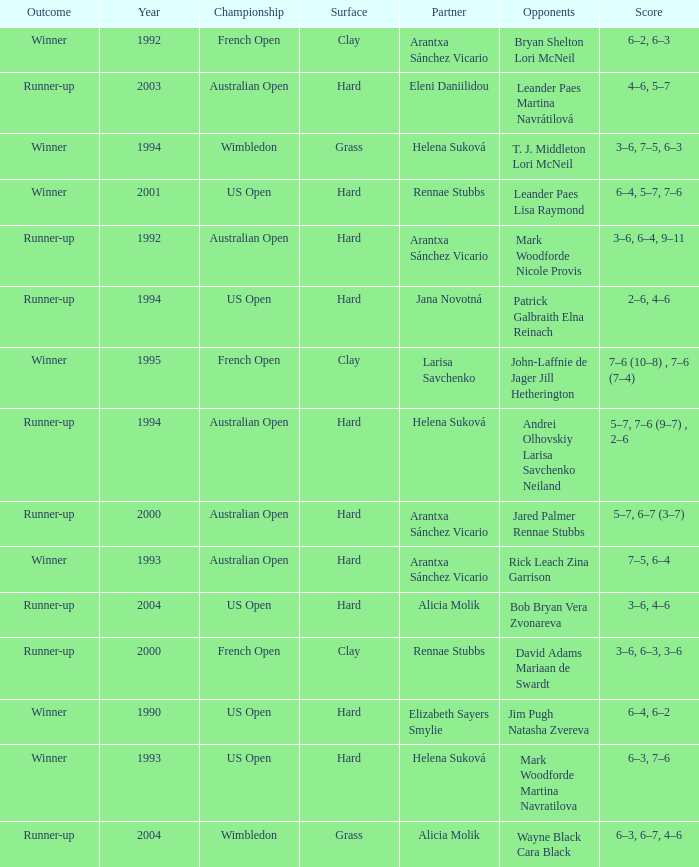Who was the Partner that was a winner, a Year smaller than 1993, and a Score of 6–4, 6–2? Elizabeth Sayers Smylie. 